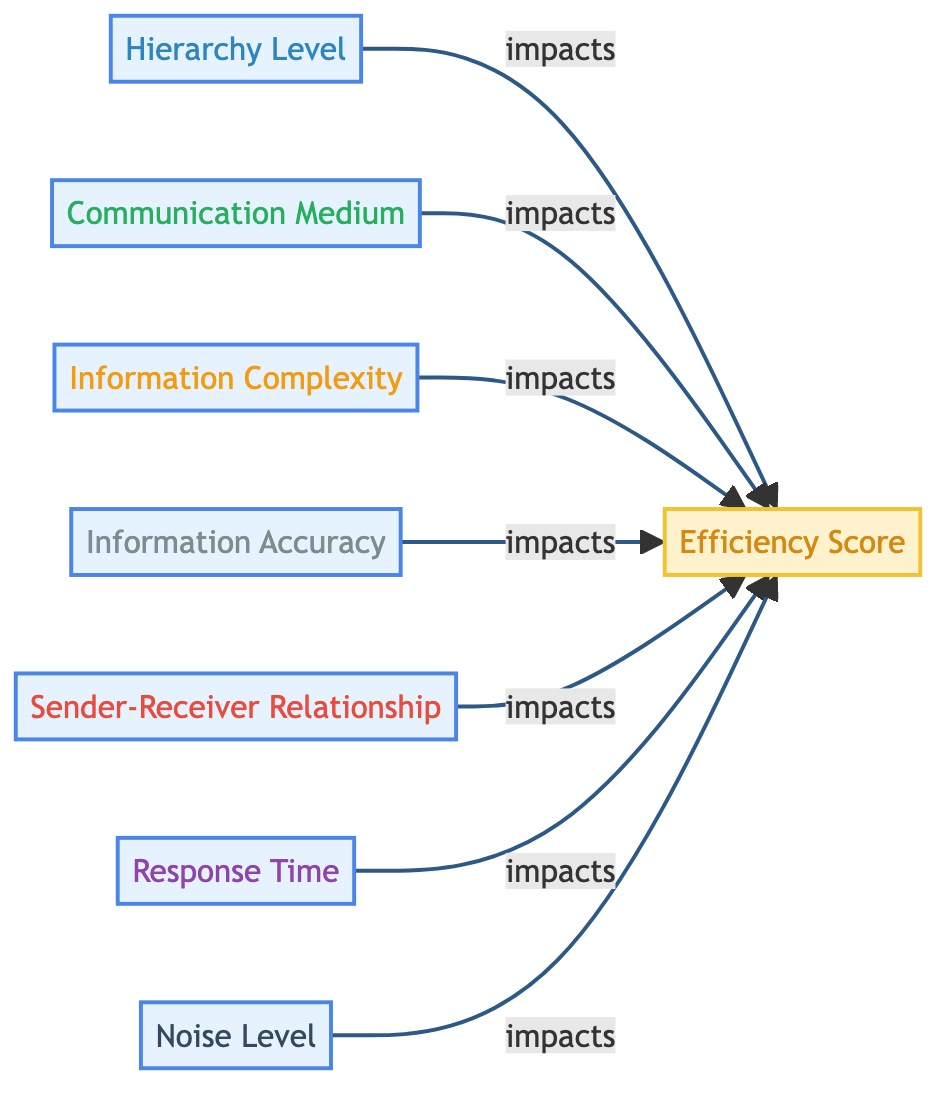What are the input nodes in this diagram? The diagram lists several input nodes which include Hierarchy Level, Communication Medium, Information Complexity, Information Accuracy, Sender-Receiver Relationship, Response Time, and Noise Level.
Answer: Hierarchy Level, Communication Medium, Information Complexity, Information Accuracy, Sender-Receiver Relationship, Response Time, Noise Level How many input nodes are present? Counting the nodes labeled as inputs in the diagram, we have seven distinct input nodes.
Answer: Seven What is the output of the diagram? The diagram indicates that the output is the Efficiency Score, which is derived from the input nodes.
Answer: Efficiency Score Which input node is related to Response Time? The diagram shows a direct relationship indicating that Response Time impacts the Efficiency Score output, linking these two nodes.
Answer: Response Time Do all input nodes lead to the same output node? Based on the diagram, all seven input nodes lead to the Efficiency Score, signifying that they all contribute to the same outcome.
Answer: Yes What is the relationship between Information Complexity and Efficiency Score? The diagram articulates that Information Complexity impacts the Efficiency Score, illustrating a direct influence on the output.
Answer: Impacts Which input has the most emotional color coding? The Sender-Receiver Relationship is highlighted with a warm red color, indicating a higher emotional value in the diagram.
Answer: Sender-Receiver Relationship If the Noise Level increases, what happens to the Efficiency Score? The diagram illustrates that as Noise Level impacts the Efficiency Score, an increase in Noise Level likely leads to a decrease in the Efficiency Score output.
Answer: Decrease In terms of hierarchy, which input node is most likely to affect efficiency the most? The diagram does not indicate a specific hierarchy among the input nodes, but various studies suggest that Hierarchy Level often has a significant impact on information efficiency in workplaces.
Answer: Hierarchy Level 